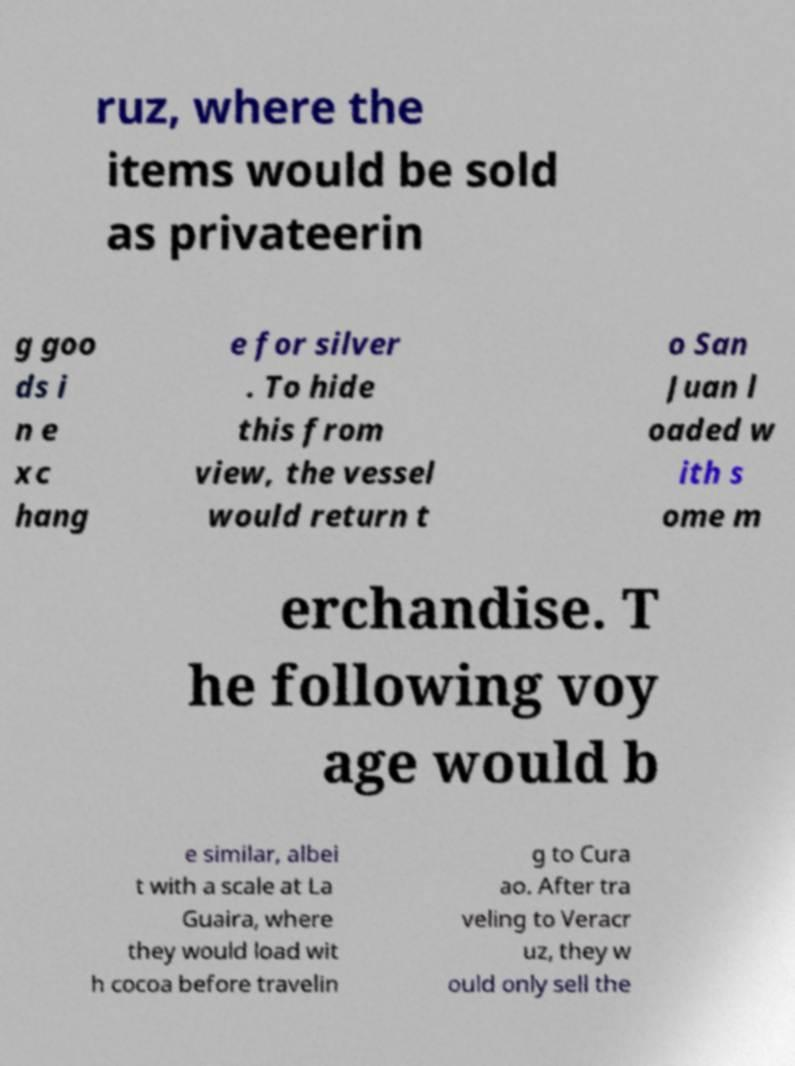Can you read and provide the text displayed in the image?This photo seems to have some interesting text. Can you extract and type it out for me? ruz, where the items would be sold as privateerin g goo ds i n e xc hang e for silver . To hide this from view, the vessel would return t o San Juan l oaded w ith s ome m erchandise. T he following voy age would b e similar, albei t with a scale at La Guaira, where they would load wit h cocoa before travelin g to Cura ao. After tra veling to Veracr uz, they w ould only sell the 